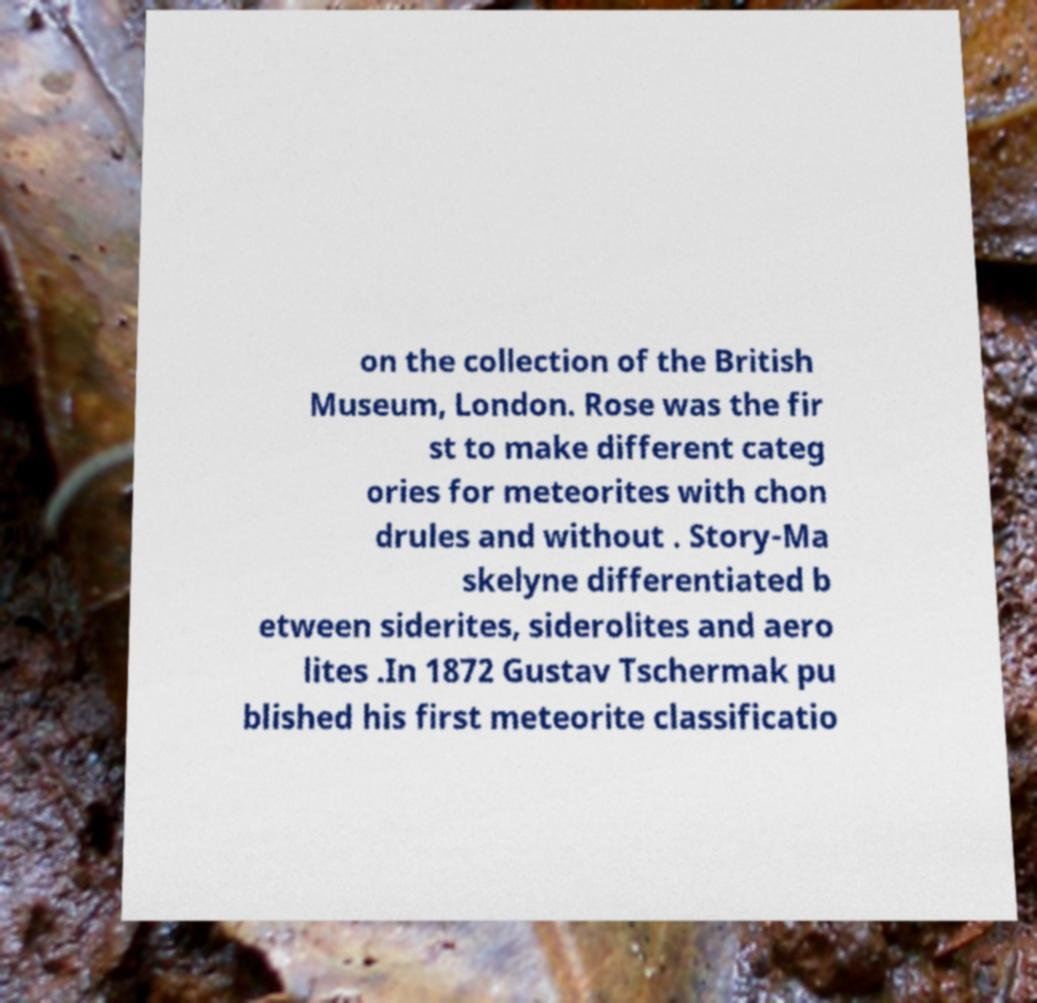Can you read and provide the text displayed in the image?This photo seems to have some interesting text. Can you extract and type it out for me? on the collection of the British Museum, London. Rose was the fir st to make different categ ories for meteorites with chon drules and without . Story-Ma skelyne differentiated b etween siderites, siderolites and aero lites .In 1872 Gustav Tschermak pu blished his first meteorite classificatio 